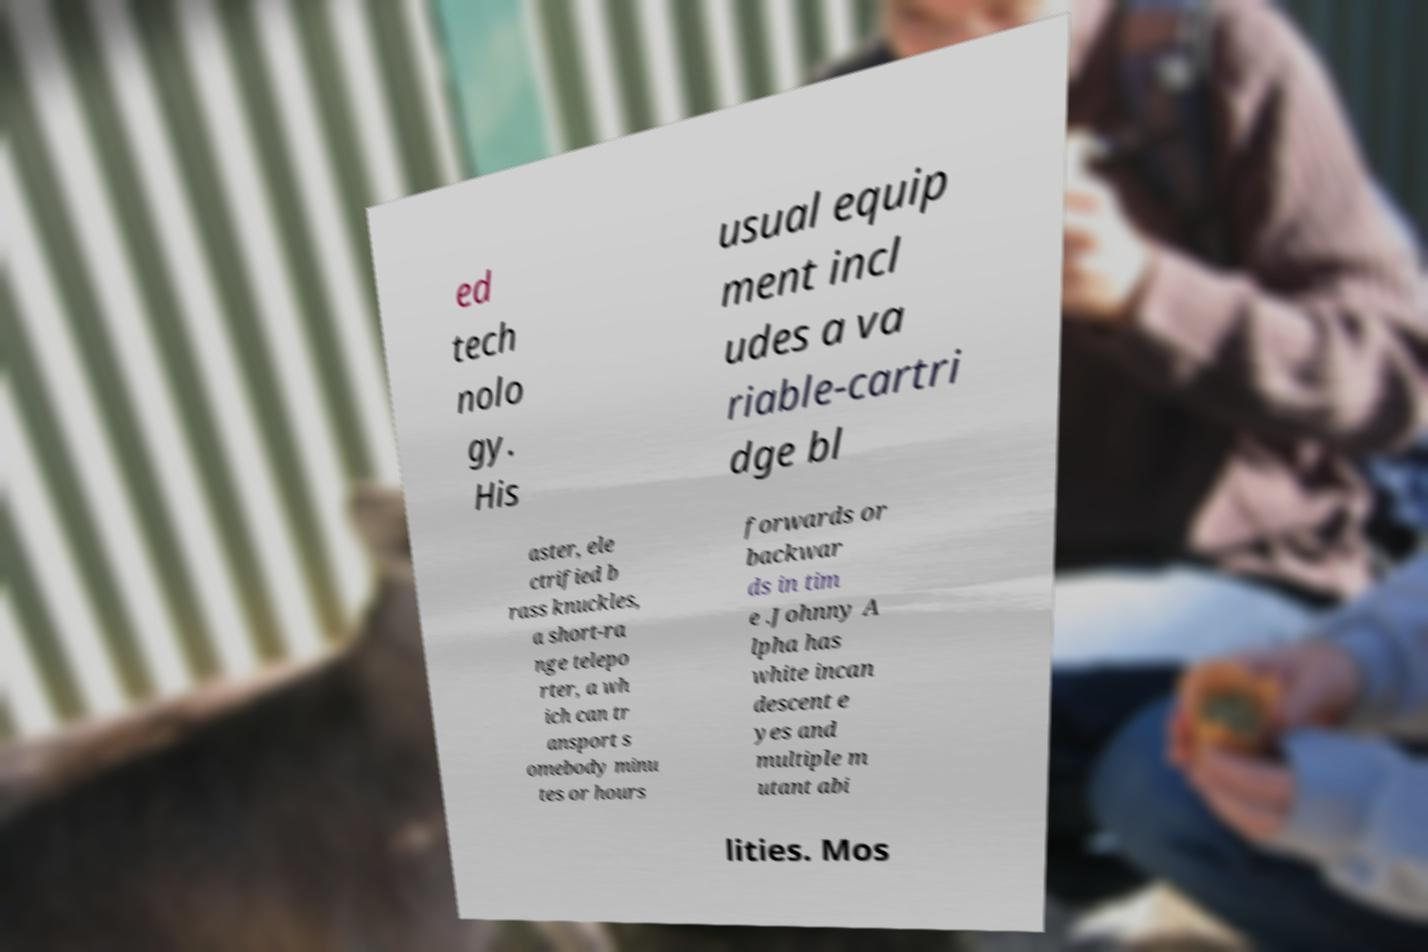There's text embedded in this image that I need extracted. Can you transcribe it verbatim? ed tech nolo gy. His usual equip ment incl udes a va riable-cartri dge bl aster, ele ctrified b rass knuckles, a short-ra nge telepo rter, a wh ich can tr ansport s omebody minu tes or hours forwards or backwar ds in tim e .Johnny A lpha has white incan descent e yes and multiple m utant abi lities. Mos 